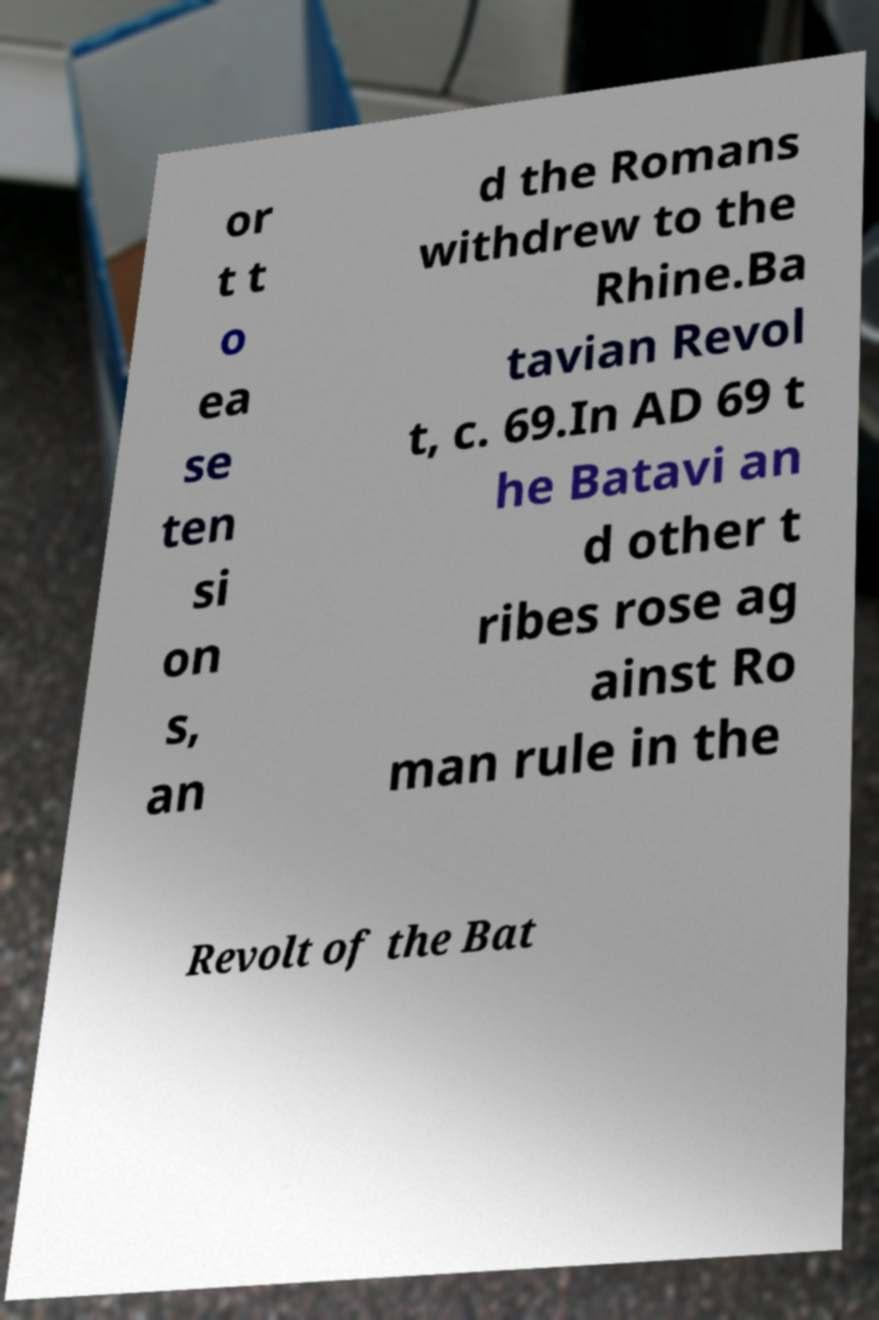Could you extract and type out the text from this image? or t t o ea se ten si on s, an d the Romans withdrew to the Rhine.Ba tavian Revol t, c. 69.In AD 69 t he Batavi an d other t ribes rose ag ainst Ro man rule in the Revolt of the Bat 